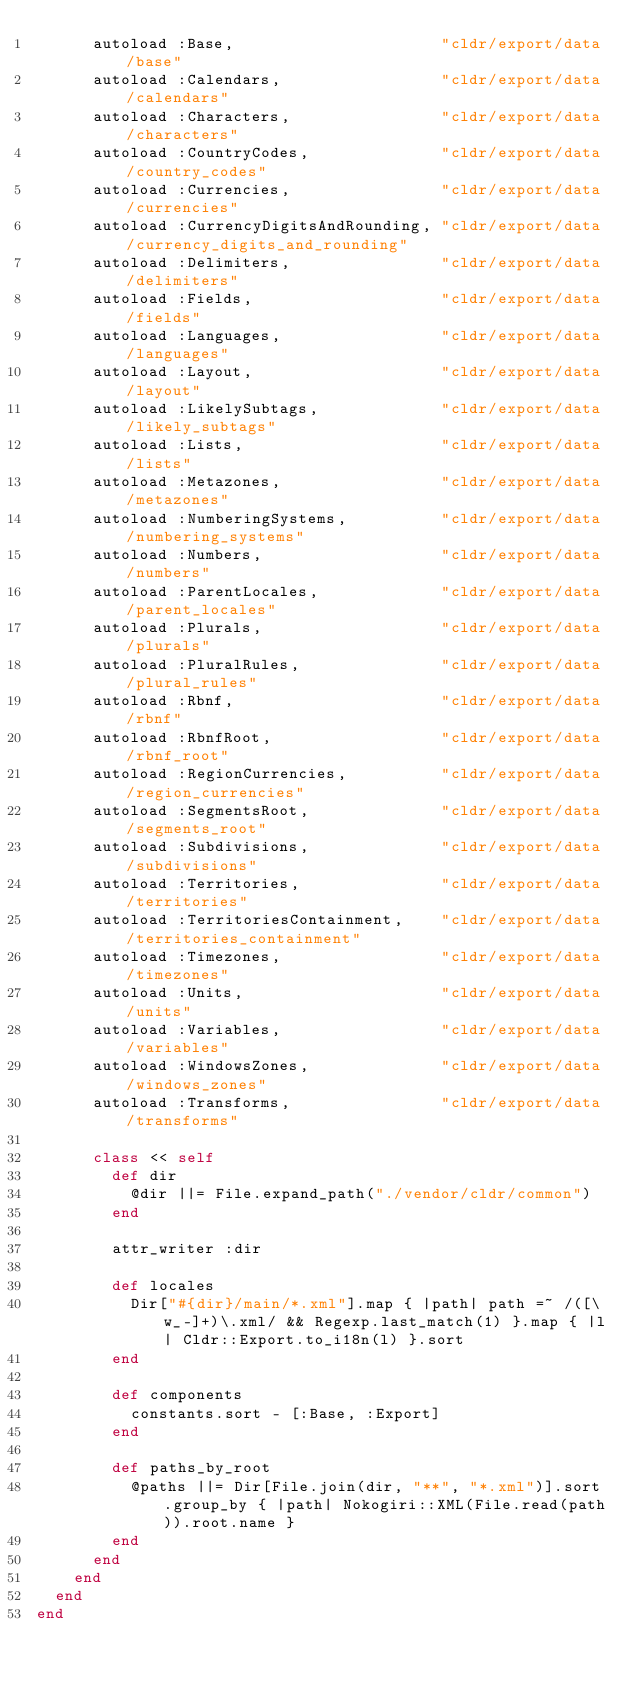Convert code to text. <code><loc_0><loc_0><loc_500><loc_500><_Ruby_>      autoload :Base,                      "cldr/export/data/base"
      autoload :Calendars,                 "cldr/export/data/calendars"
      autoload :Characters,                "cldr/export/data/characters"
      autoload :CountryCodes,              "cldr/export/data/country_codes"
      autoload :Currencies,                "cldr/export/data/currencies"
      autoload :CurrencyDigitsAndRounding, "cldr/export/data/currency_digits_and_rounding"
      autoload :Delimiters,                "cldr/export/data/delimiters"
      autoload :Fields,                    "cldr/export/data/fields"
      autoload :Languages,                 "cldr/export/data/languages"
      autoload :Layout,                    "cldr/export/data/layout"
      autoload :LikelySubtags,             "cldr/export/data/likely_subtags"
      autoload :Lists,                     "cldr/export/data/lists"
      autoload :Metazones,                 "cldr/export/data/metazones"
      autoload :NumberingSystems,          "cldr/export/data/numbering_systems"
      autoload :Numbers,                   "cldr/export/data/numbers"
      autoload :ParentLocales,             "cldr/export/data/parent_locales"
      autoload :Plurals,                   "cldr/export/data/plurals"
      autoload :PluralRules,               "cldr/export/data/plural_rules"
      autoload :Rbnf,                      "cldr/export/data/rbnf"
      autoload :RbnfRoot,                  "cldr/export/data/rbnf_root"
      autoload :RegionCurrencies,          "cldr/export/data/region_currencies"
      autoload :SegmentsRoot,              "cldr/export/data/segments_root"
      autoload :Subdivisions,              "cldr/export/data/subdivisions"
      autoload :Territories,               "cldr/export/data/territories"
      autoload :TerritoriesContainment,    "cldr/export/data/territories_containment"
      autoload :Timezones,                 "cldr/export/data/timezones"
      autoload :Units,                     "cldr/export/data/units"
      autoload :Variables,                 "cldr/export/data/variables"
      autoload :WindowsZones,              "cldr/export/data/windows_zones"
      autoload :Transforms,                "cldr/export/data/transforms"

      class << self
        def dir
          @dir ||= File.expand_path("./vendor/cldr/common")
        end

        attr_writer :dir

        def locales
          Dir["#{dir}/main/*.xml"].map { |path| path =~ /([\w_-]+)\.xml/ && Regexp.last_match(1) }.map { |l| Cldr::Export.to_i18n(l) }.sort
        end

        def components
          constants.sort - [:Base, :Export]
        end

        def paths_by_root
          @paths ||= Dir[File.join(dir, "**", "*.xml")].sort.group_by { |path| Nokogiri::XML(File.read(path)).root.name }
        end
      end
    end
  end
end
</code> 